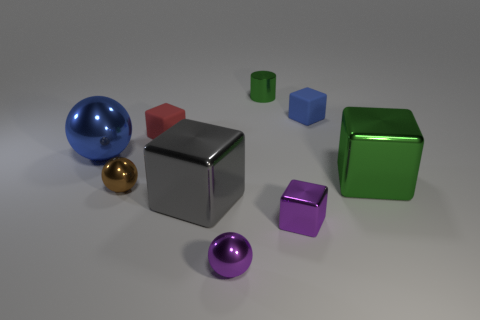Subtract all green cubes. How many cubes are left? 4 Subtract all gray blocks. How many blocks are left? 4 Add 1 tiny purple metal cubes. How many objects exist? 10 Subtract all purple blocks. Subtract all green spheres. How many blocks are left? 4 Subtract all spheres. How many objects are left? 6 Subtract all tiny metal blocks. Subtract all tiny cubes. How many objects are left? 5 Add 4 tiny brown balls. How many tiny brown balls are left? 5 Add 2 yellow metallic spheres. How many yellow metallic spheres exist? 2 Subtract 1 blue balls. How many objects are left? 8 